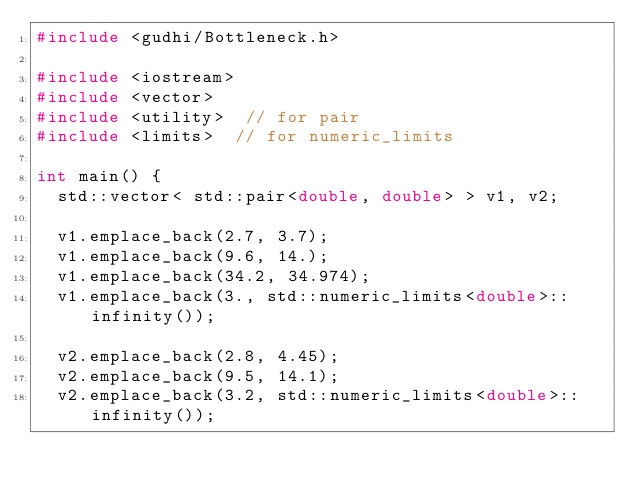<code> <loc_0><loc_0><loc_500><loc_500><_C++_>#include <gudhi/Bottleneck.h>

#include <iostream>
#include <vector>
#include <utility>  // for pair
#include <limits>  // for numeric_limits

int main() {
  std::vector< std::pair<double, double> > v1, v2;

  v1.emplace_back(2.7, 3.7);
  v1.emplace_back(9.6, 14.);
  v1.emplace_back(34.2, 34.974);
  v1.emplace_back(3., std::numeric_limits<double>::infinity());

  v2.emplace_back(2.8, 4.45);
  v2.emplace_back(9.5, 14.1);
  v2.emplace_back(3.2, std::numeric_limits<double>::infinity());

</code> 